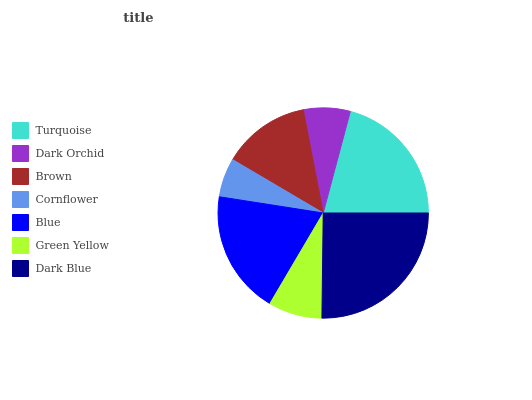Is Cornflower the minimum?
Answer yes or no. Yes. Is Dark Blue the maximum?
Answer yes or no. Yes. Is Dark Orchid the minimum?
Answer yes or no. No. Is Dark Orchid the maximum?
Answer yes or no. No. Is Turquoise greater than Dark Orchid?
Answer yes or no. Yes. Is Dark Orchid less than Turquoise?
Answer yes or no. Yes. Is Dark Orchid greater than Turquoise?
Answer yes or no. No. Is Turquoise less than Dark Orchid?
Answer yes or no. No. Is Brown the high median?
Answer yes or no. Yes. Is Brown the low median?
Answer yes or no. Yes. Is Green Yellow the high median?
Answer yes or no. No. Is Blue the low median?
Answer yes or no. No. 